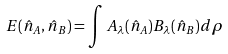Convert formula to latex. <formula><loc_0><loc_0><loc_500><loc_500>E ( \hat { n } _ { A } , \hat { n } _ { B } ) = \int A _ { \lambda } ( \hat { n } _ { A } ) B _ { \lambda } ( \hat { n } _ { B } ) d \rho</formula> 